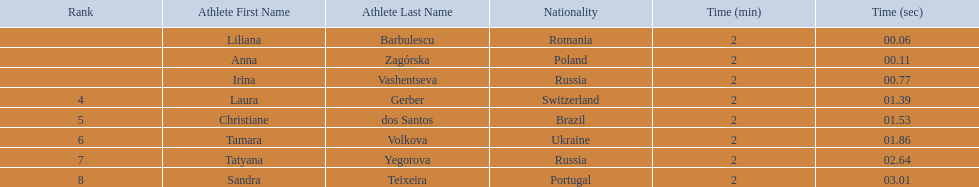Who came in second place at the athletics at the 2003 summer universiade - women's 800 metres? Anna Zagórska. What was her time? 2:00.11. 